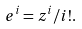<formula> <loc_0><loc_0><loc_500><loc_500>e ^ { i } = z ^ { i } / i ! .</formula> 